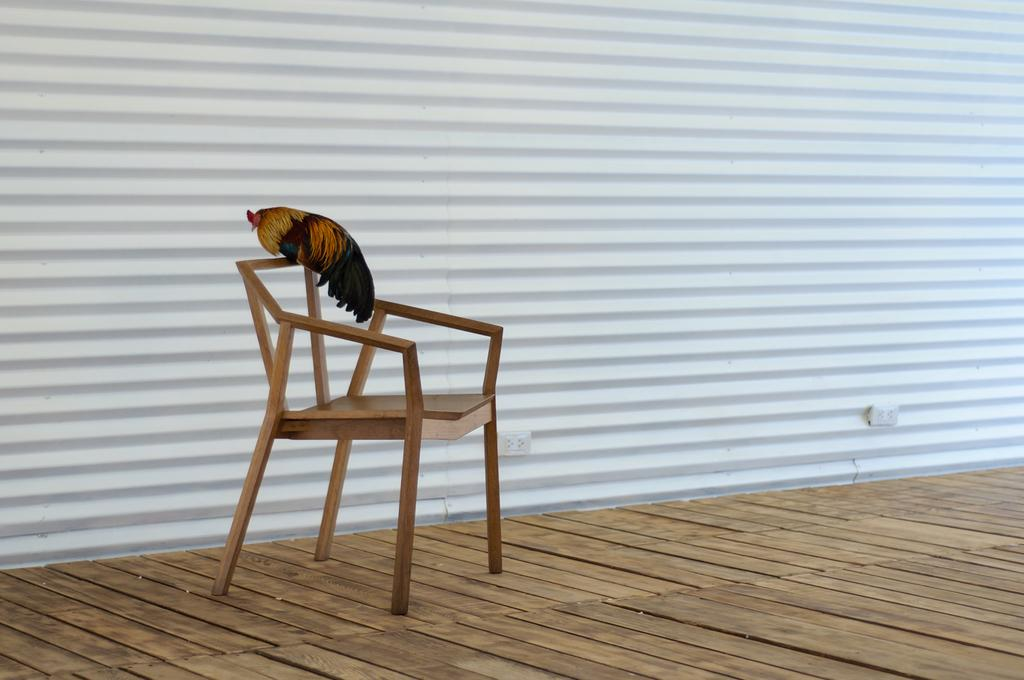What type of animal is in the image? There is a cock in the image. Where is the cock located? The cock is on a chair. What can be seen in the background of the image? There is a wall in the background of the image. What type of apparel is the cock wearing in the image? The cock is not wearing any apparel in the image. Can you see the ocean in the background of the image? No, the ocean is not present in the image; there is only a wall visible in the background. 